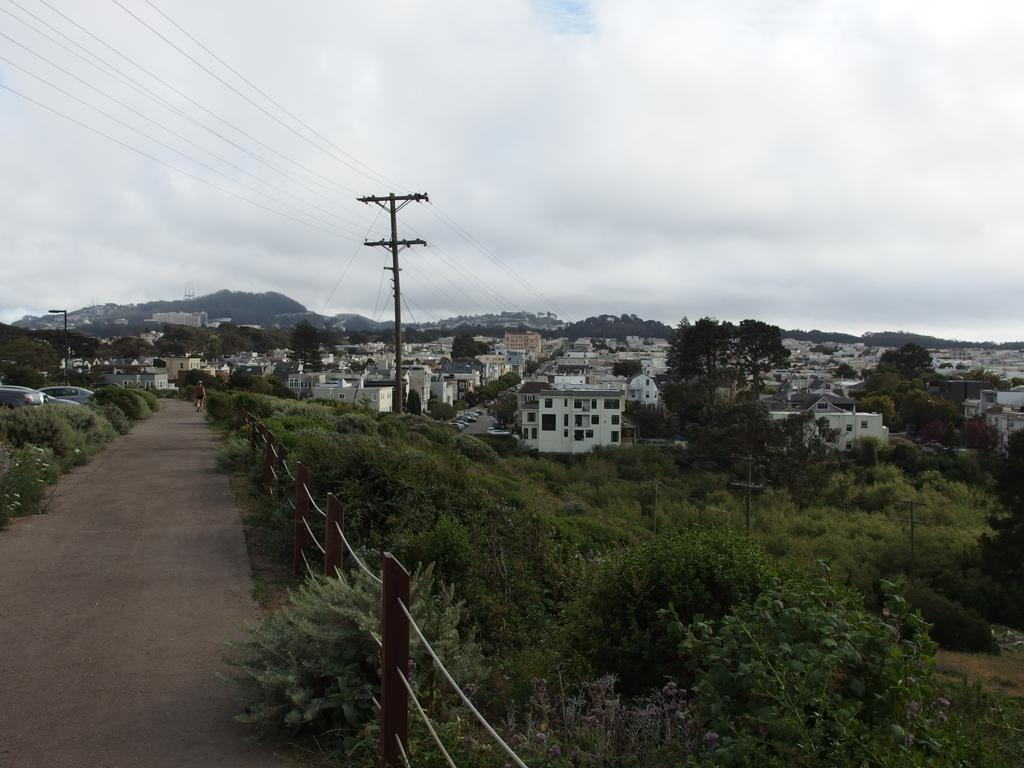What type of structures can be seen in the image? There are buildings in the image. What other natural elements are present in the image? There are trees in the image. What object can be seen standing upright in the image? There is a pole in the image. How would you describe the weather based on the image? The sky is cloudy in the image. How much meat is hanging from the pole in the image? There is no meat hanging from the pole in the image; it is a pole without any meat. 